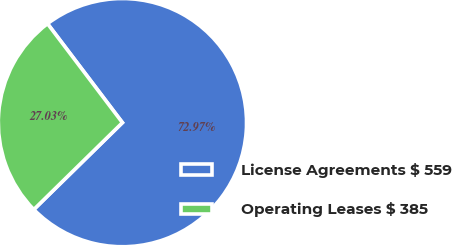<chart> <loc_0><loc_0><loc_500><loc_500><pie_chart><fcel>License Agreements $ 559<fcel>Operating Leases $ 385<nl><fcel>72.97%<fcel>27.03%<nl></chart> 